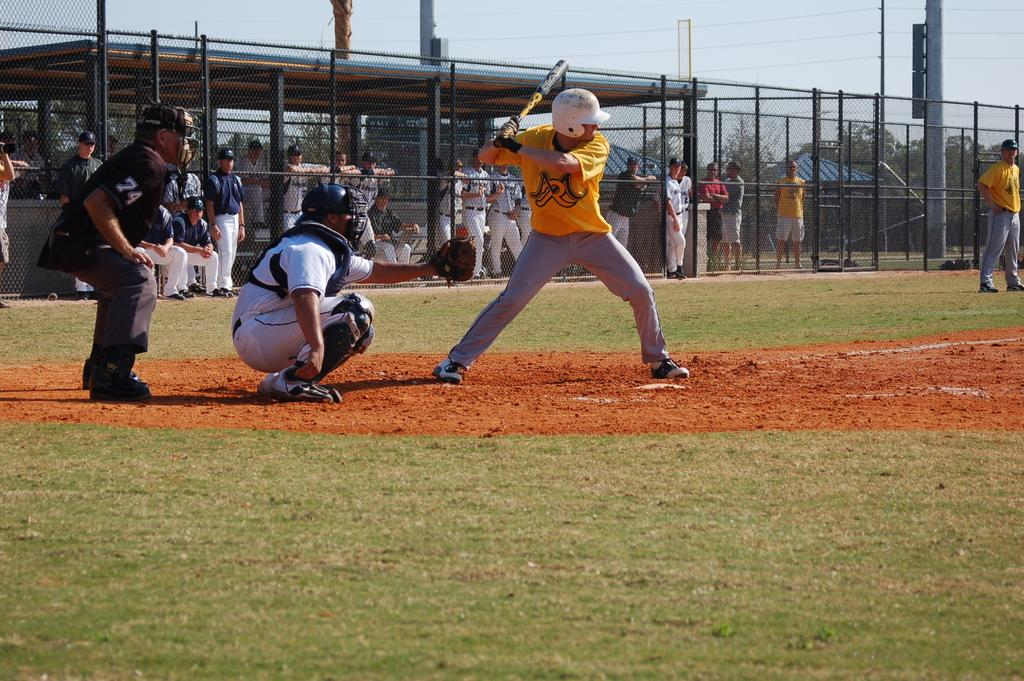<image>
Summarize the visual content of the image. a baseball player that has the letter R on their jersey 